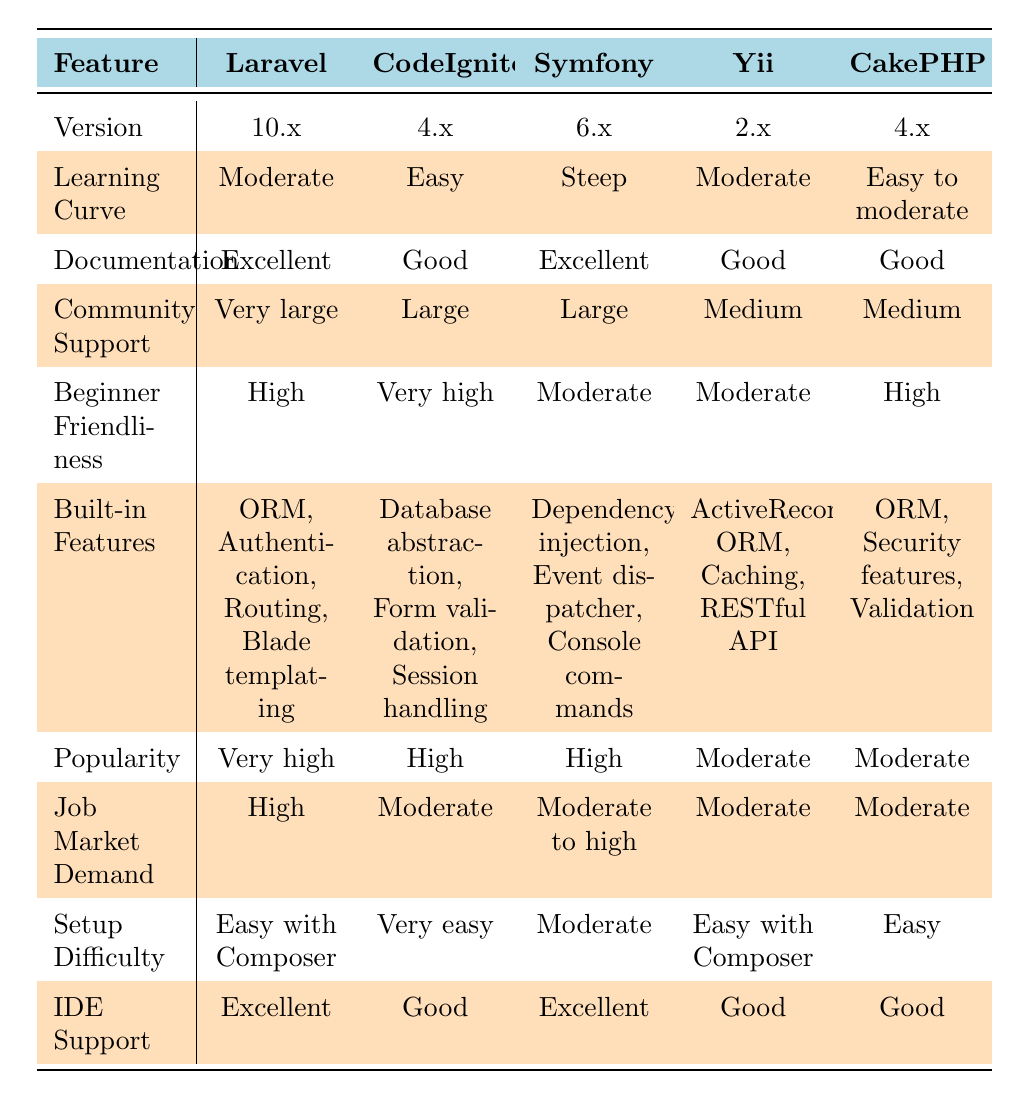What is the version number of Laravel? The table lists Laravel under the 'Version' row, showing the version number as 10.x.
Answer: 10.x Which framework has the easiest learning curve? The learning curves are listed, and CodeIgniter is marked as 'Easy', which is the simplest compared to others.
Answer: CodeIgniter Does Symfony have a very high beginner friendliness rating? The table indicates that Symfony has a 'Moderate' rating for beginner friendliness, which is not very high.
Answer: No Which frameworks have excellent documentation quality? By examining the documentation quality, both Laravel and Symfony are noted to have 'Excellent' documentation.
Answer: Laravel, Symfony What is the setup difficulty of Yii? The table specifies that the setup difficulty for Yii is 'Easy with Composer'.
Answer: Easy with Composer How many frameworks have a medium level of community support? By reviewing the community support ratings, Yii and CakePHP both have 'Medium' community support, so there are two frameworks that meet this criterion.
Answer: 2 Do all the frameworks listed support IDEs? The table shows that all frameworks have some level of IDE support, with Laravel and Symfony having 'Excellent', while others are rated as 'Good'.
Answer: Yes Which framework is popular but has moderate job market demand? The popularity and job market demand metrics indicate that Yii is 'Moderate' in popularity and 'Moderate' in job market demand.
Answer: Yii Is there any framework that has both easy setup difficulty and high beginner friendliness? Analyzing the table, CodeIgniter has 'Very easy' setup difficulty and 'Very high' beginner friendliness, indicating it meets both criteria.
Answer: Yes 